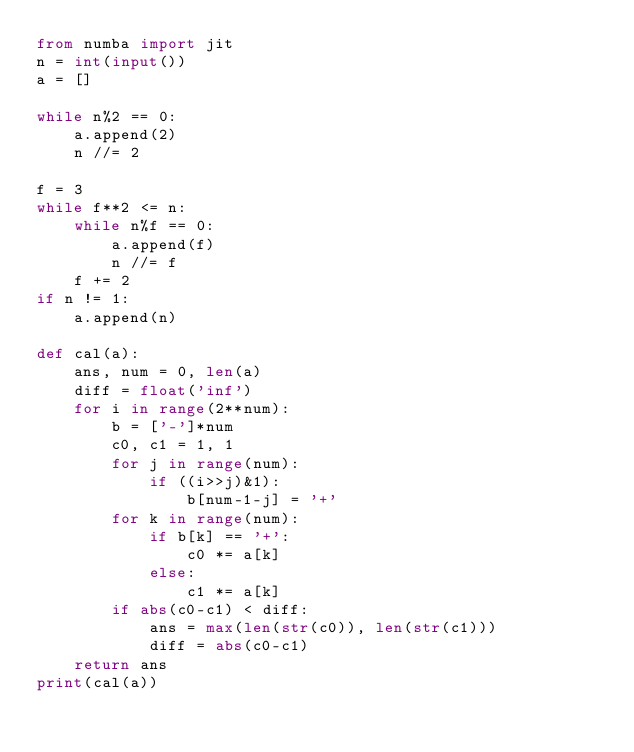Convert code to text. <code><loc_0><loc_0><loc_500><loc_500><_Python_>from numba import jit
n = int(input())
a = []

while n%2 == 0:
    a.append(2)
    n //= 2

f = 3
while f**2 <= n:
    while n%f == 0:
        a.append(f)
        n //= f
    f += 2
if n != 1:
    a.append(n)

def cal(a):
    ans, num = 0, len(a)
    diff = float('inf')
    for i in range(2**num):
        b = ['-']*num
        c0, c1 = 1, 1
        for j in range(num):
            if ((i>>j)&1):
                b[num-1-j] = '+'
        for k in range(num):
            if b[k] == '+':
                c0 *= a[k]
            else:
                c1 *= a[k]
        if abs(c0-c1) < diff:
            ans = max(len(str(c0)), len(str(c1)))
            diff = abs(c0-c1)
    return ans
print(cal(a))
</code> 